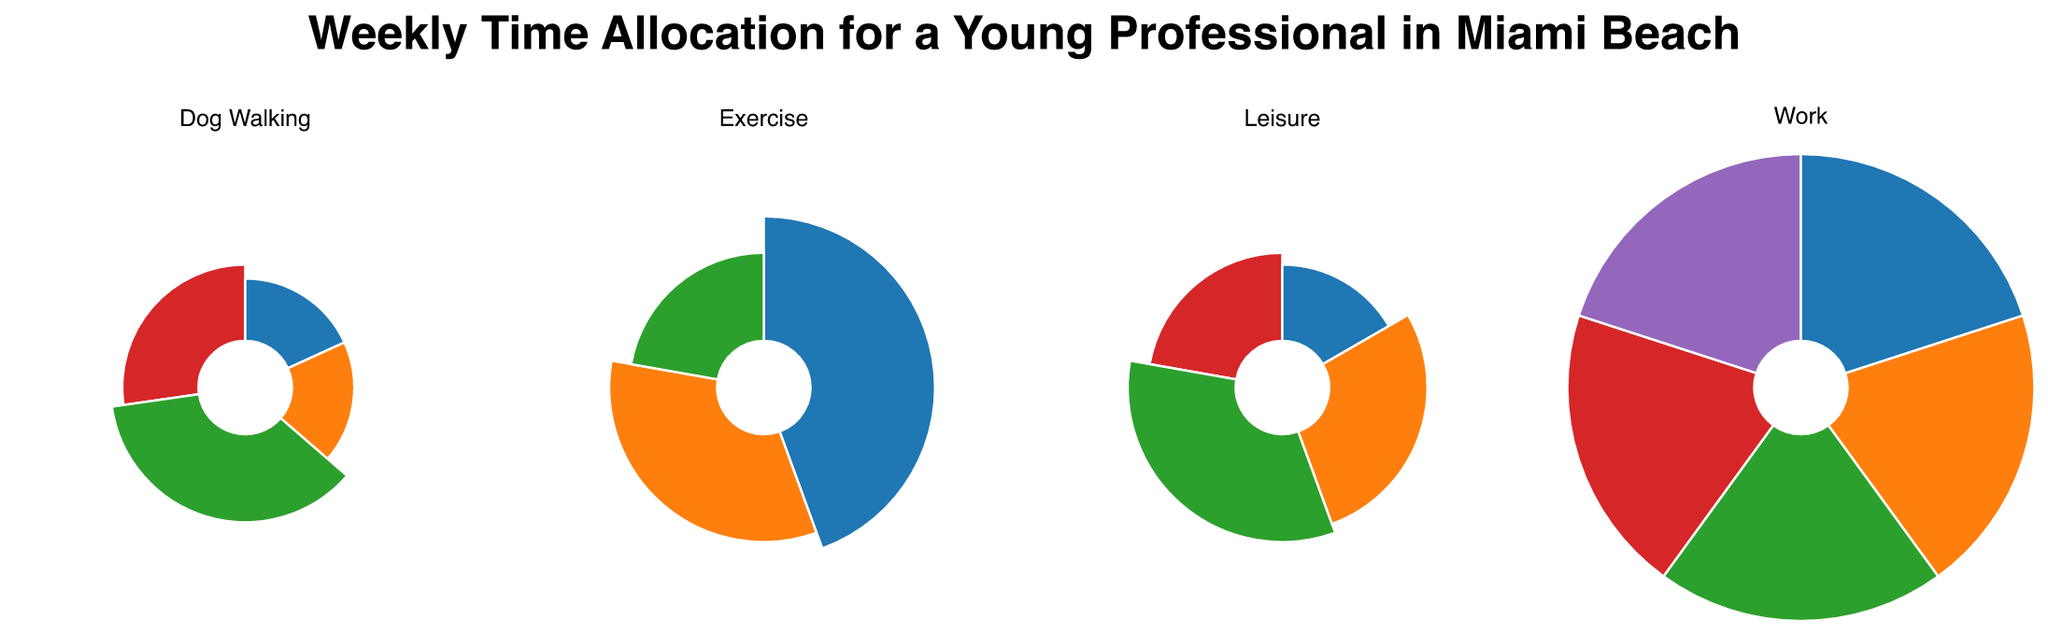What's the title of the figure? The title is usually located at the top center of the figure.
Answer: Weekly Time Allocation for a Young Professional in Miami Beach How many categories of activities are represented in the figure? By looking at the different segmented areas and their labels, we can count the distinct categories.
Answer: Four (Work, Leisure, Exercise, Dog Walking) Which leisure activity has the highest allocated hours? By checking the areas corresponding to Leisure activities, we find that South Beach has the largest segment.
Answer: South Beach How many total hours are spent on exercise in a week? Add up the hours for Jogging, Gym, and Swimming. 3 + 4 + 2 = 9 hours
Answer: 9 hours Which category has the smallest number of activities? Contrast the number of activities in each category. Dog Walking has 4, Leisure 4, Exercise 3, Work 5. Exercise has the smallest number.
Answer: Exercise What is the difference in hours spent on Dog Walking between North Shore Open Space Park and Lummus Park? Compare the hours given for North Shore Open Space Park (2) and Lummus Park (1). The difference is 2 - 1 = 1 hour
Answer: 1 hour How does the total time spent on work compare to the total time spent on leisure activities? Sum the hours for Work (5 days, each 9 hours, so 5 * 9 = 45 hours) and compare them with the sum of hours for Leisure activities (2 + 3 + 1.5 + 2.5 = 9 hours). Work has 45 hours and Leisure has 9 hours.
Answer: Work has 36 hours more than Leisure Which exercise activity takes up the most time? Compare the segments for Jogging, Gym, and Swimming to see which has the largest area. Gym has the largest area.
Answer: Gym How many parks are visited during dog walking? Count the distinct park names under the Dog Walking category. South Pointe Park, Lummus Park, Collins Park, and North Shore Open Space Park make a total of four unique parks.
Answer: Four parks If you wanted to balance the time spent between work and leisure, how many hours should be reallocated from work to leisure? Total time spent on work is 45 hours. Total time spent on leisure is 9 hours. To balance, they each should have 27 hours. So, 45 - 27 = 18 hours should be reallocated from work to leisure.
Answer: 18 hours 